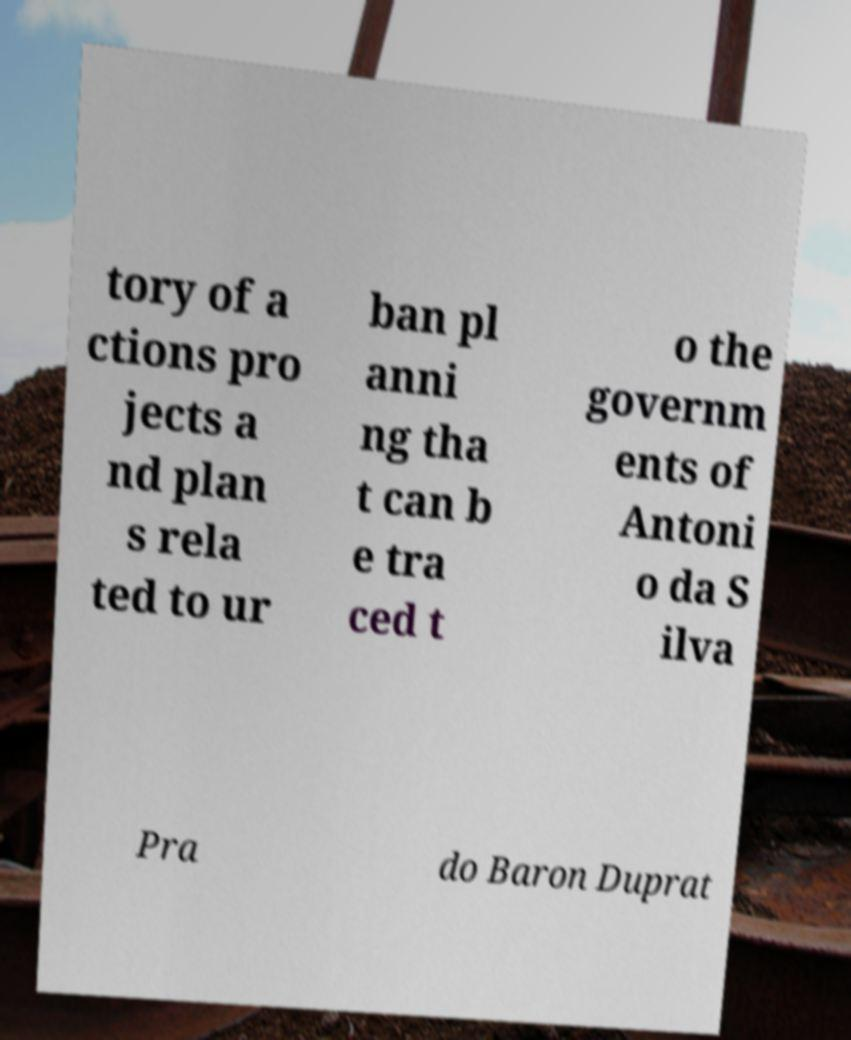Could you extract and type out the text from this image? tory of a ctions pro jects a nd plan s rela ted to ur ban pl anni ng tha t can b e tra ced t o the governm ents of Antoni o da S ilva Pra do Baron Duprat 